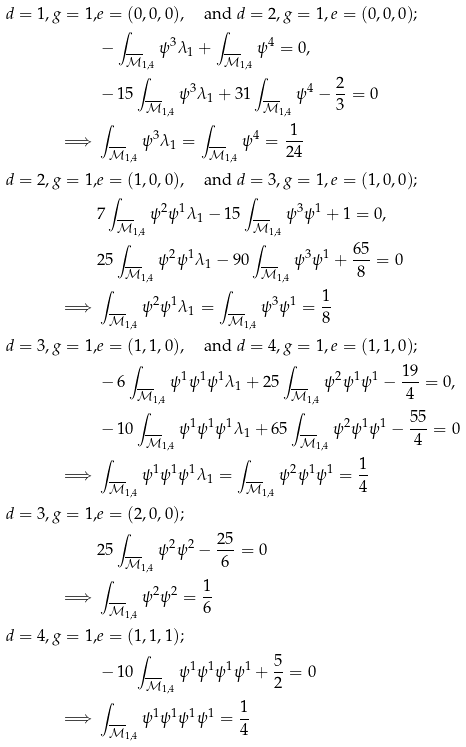Convert formula to latex. <formula><loc_0><loc_0><loc_500><loc_500>d = 1 , g = 1 , & e = ( 0 , 0 , 0 ) , \quad \text {and } d = 2 , g = 1 , e = ( 0 , 0 , 0 ) ; \\ & - \int _ { \overline { \mathcal { M } } _ { 1 , 4 } } \psi ^ { 3 } \lambda _ { 1 } + \int _ { \overline { \mathcal { M } } _ { 1 , 4 } } \psi ^ { 4 } = 0 , \\ & - 1 5 \int _ { \overline { \mathcal { M } } _ { 1 , 4 } } \psi ^ { 3 } \lambda _ { 1 } + 3 1 \int _ { \overline { \mathcal { M } } _ { 1 , 4 } } \psi ^ { 4 } - \frac { 2 } { 3 } = 0 \\ \implies & \int _ { \overline { \mathcal { M } } _ { 1 , 4 } } \psi ^ { 3 } \lambda _ { 1 } = \int _ { \overline { \mathcal { M } } _ { 1 , 4 } } \psi ^ { 4 } = \frac { 1 } { 2 4 } \\ d = 2 , g = 1 , & e = ( 1 , 0 , 0 ) , \quad \text {and } d = 3 , g = 1 , e = ( 1 , 0 , 0 ) ; \\ & 7 \int _ { \overline { \mathcal { M } } _ { 1 , 4 } } \psi ^ { 2 } \psi ^ { 1 } \lambda _ { 1 } - 1 5 \int _ { \overline { \mathcal { M } } _ { 1 , 4 } } \psi ^ { 3 } \psi ^ { 1 } + 1 = 0 , \\ & 2 5 \int _ { \overline { \mathcal { M } } _ { 1 , 4 } } \psi ^ { 2 } \psi ^ { 1 } \lambda _ { 1 } - 9 0 \int _ { \overline { \mathcal { M } } _ { 1 , 4 } } \psi ^ { 3 } \psi ^ { 1 } + \frac { 6 5 } { 8 } = 0 \\ \implies & \int _ { \overline { \mathcal { M } } _ { 1 , 4 } } \psi ^ { 2 } \psi ^ { 1 } \lambda _ { 1 } = \int _ { \overline { \mathcal { M } } _ { 1 , 4 } } \psi ^ { 3 } \psi ^ { 1 } = \frac { 1 } { 8 } \\ d = 3 , g = 1 , & e = ( 1 , 1 , 0 ) , \quad \text {and } d = 4 , g = 1 , e = ( 1 , 1 , 0 ) ; \\ & - 6 \int _ { \overline { \mathcal { M } } _ { 1 , 4 } } \psi ^ { 1 } \psi ^ { 1 } \psi ^ { 1 } \lambda _ { 1 } + 2 5 \int _ { \overline { \mathcal { M } } _ { 1 , 4 } } \psi ^ { 2 } \psi ^ { 1 } \psi ^ { 1 } - \frac { 1 9 } { 4 } = 0 , \\ & - 1 0 \int _ { \overline { \mathcal { M } } _ { 1 , 4 } } \psi ^ { 1 } \psi ^ { 1 } \psi ^ { 1 } \lambda _ { 1 } + 6 5 \int _ { \overline { \mathcal { M } } _ { 1 , 4 } } \psi ^ { 2 } \psi ^ { 1 } \psi ^ { 1 } - \frac { 5 5 } { 4 } = 0 \\ \implies & \int _ { \overline { \mathcal { M } } _ { 1 , 4 } } \psi ^ { 1 } \psi ^ { 1 } \psi ^ { 1 } \lambda _ { 1 } = \int _ { \overline { \mathcal { M } } _ { 1 , 4 } } \psi ^ { 2 } \psi ^ { 1 } \psi ^ { 1 } = \frac { 1 } { 4 } \\ d = 3 , g = 1 , & e = ( 2 , 0 , 0 ) ; \\ & 2 5 \int _ { \overline { \mathcal { M } } _ { 1 , 4 } } \psi ^ { 2 } \psi ^ { 2 } - \frac { 2 5 } { 6 } = 0 \\ \implies & \int _ { \overline { \mathcal { M } } _ { 1 , 4 } } \psi ^ { 2 } \psi ^ { 2 } = \frac { 1 } { 6 } \\ d = 4 , g = 1 , & e = ( 1 , 1 , 1 ) ; \\ & - 1 0 \int _ { \overline { \mathcal { M } } _ { 1 , 4 } } \psi ^ { 1 } \psi ^ { 1 } \psi ^ { 1 } \psi ^ { 1 } + \frac { 5 } { 2 } = 0 \\ \implies & \int _ { \overline { \mathcal { M } } _ { 1 , 4 } } \psi ^ { 1 } \psi ^ { 1 } \psi ^ { 1 } \psi ^ { 1 } = \frac { 1 } { 4 }</formula> 